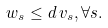<formula> <loc_0><loc_0><loc_500><loc_500>w _ { s } \leq d \, v _ { s } , \forall s .</formula> 